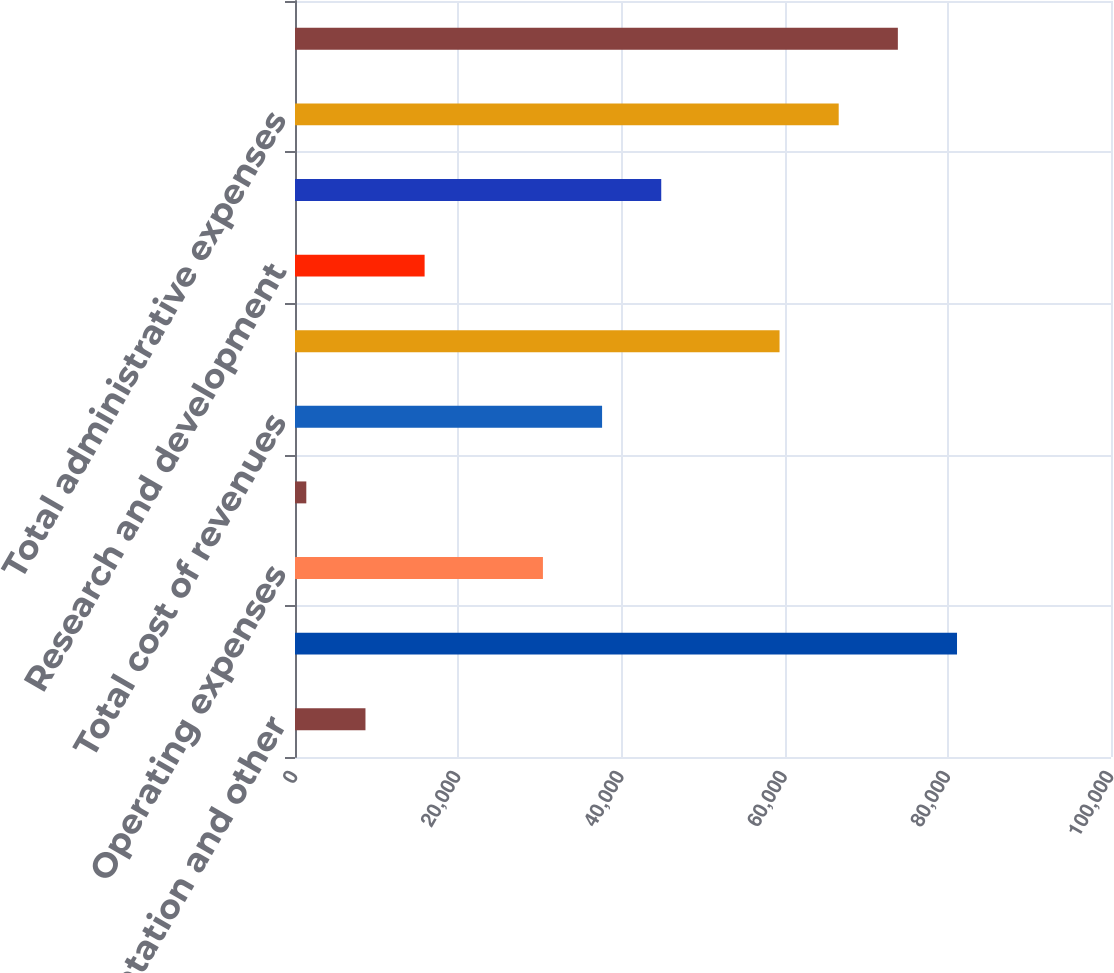Convert chart. <chart><loc_0><loc_0><loc_500><loc_500><bar_chart><fcel>Implementation and other<fcel>Total revenues<fcel>Operating expenses<fcel>Depreciation and amortization<fcel>Total cost of revenues<fcel>Sales and marketing<fcel>Research and development<fcel>General and administrative<fcel>Total administrative expenses<fcel>Total operating expenses<nl><fcel>8635.4<fcel>81129.4<fcel>30383.6<fcel>1386<fcel>37633<fcel>59381.2<fcel>15884.8<fcel>44882.4<fcel>66630.6<fcel>73880<nl></chart> 